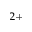Convert formula to latex. <formula><loc_0><loc_0><loc_500><loc_500>^ { 2 + }</formula> 